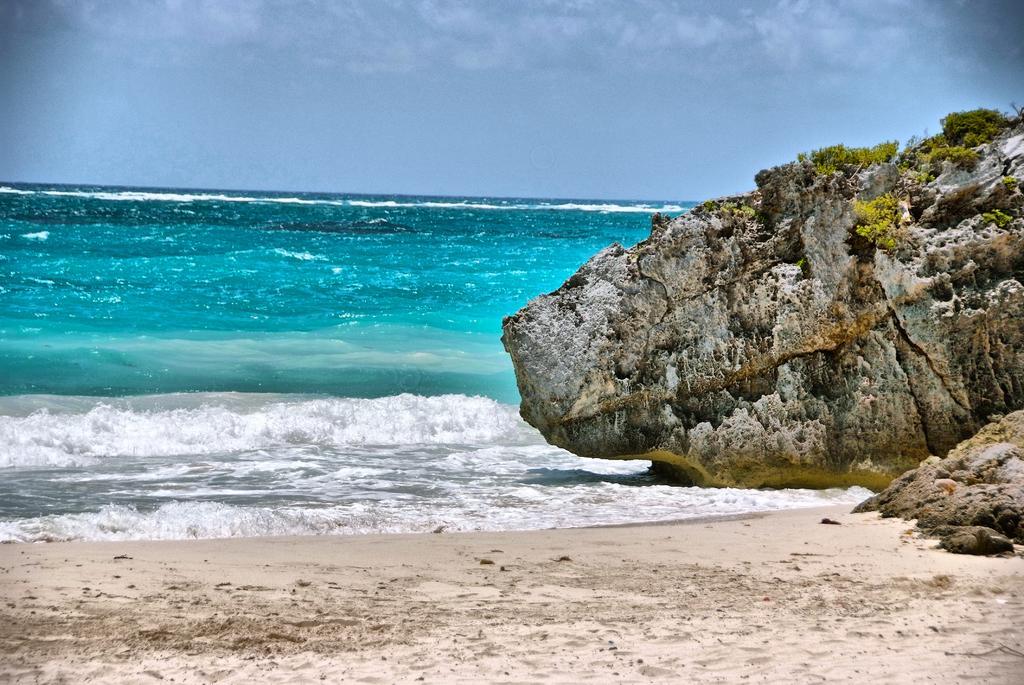Please provide a concise description of this image. This picture is clicked outside. In the foreground we can see the ground. On the right we can see the rocks and the green grass. In the center we can see a water body and the ripples in the water body. In the background we can see the sky. 